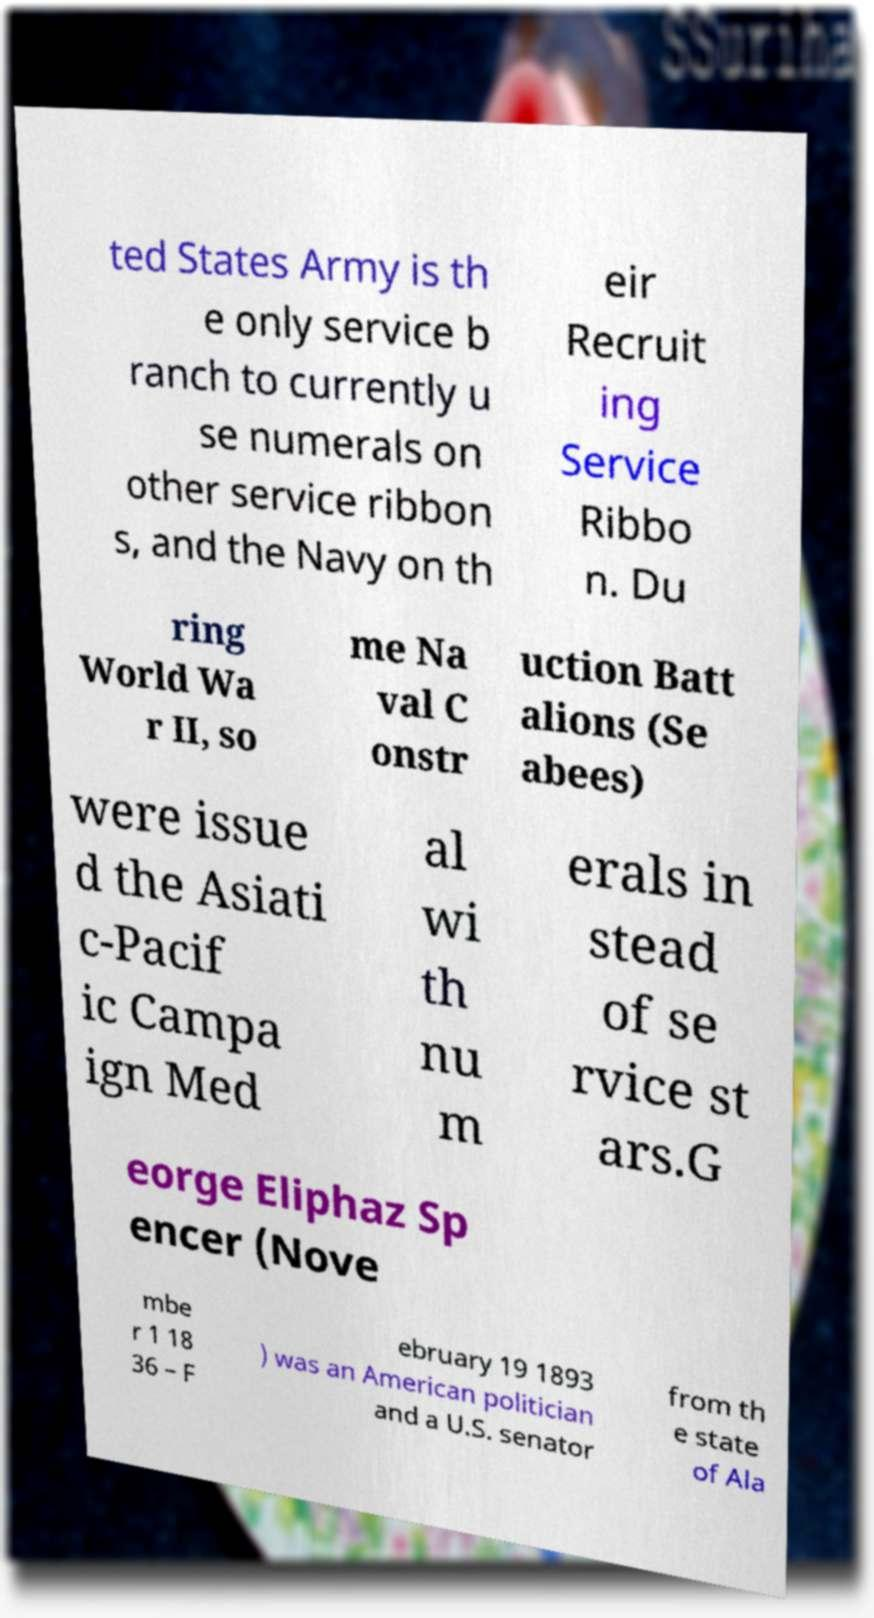Please identify and transcribe the text found in this image. ted States Army is th e only service b ranch to currently u se numerals on other service ribbon s, and the Navy on th eir Recruit ing Service Ribbo n. Du ring World Wa r II, so me Na val C onstr uction Batt alions (Se abees) were issue d the Asiati c-Pacif ic Campa ign Med al wi th nu m erals in stead of se rvice st ars.G eorge Eliphaz Sp encer (Nove mbe r 1 18 36 – F ebruary 19 1893 ) was an American politician and a U.S. senator from th e state of Ala 